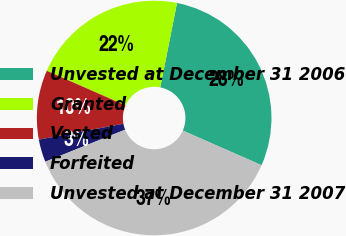Convert chart. <chart><loc_0><loc_0><loc_500><loc_500><pie_chart><fcel>Unvested at December 31 2006<fcel>Granted<fcel>Vested<fcel>Forfeited<fcel>Unvested at December 31 2007<nl><fcel>28.47%<fcel>21.53%<fcel>9.54%<fcel>3.13%<fcel>37.33%<nl></chart> 